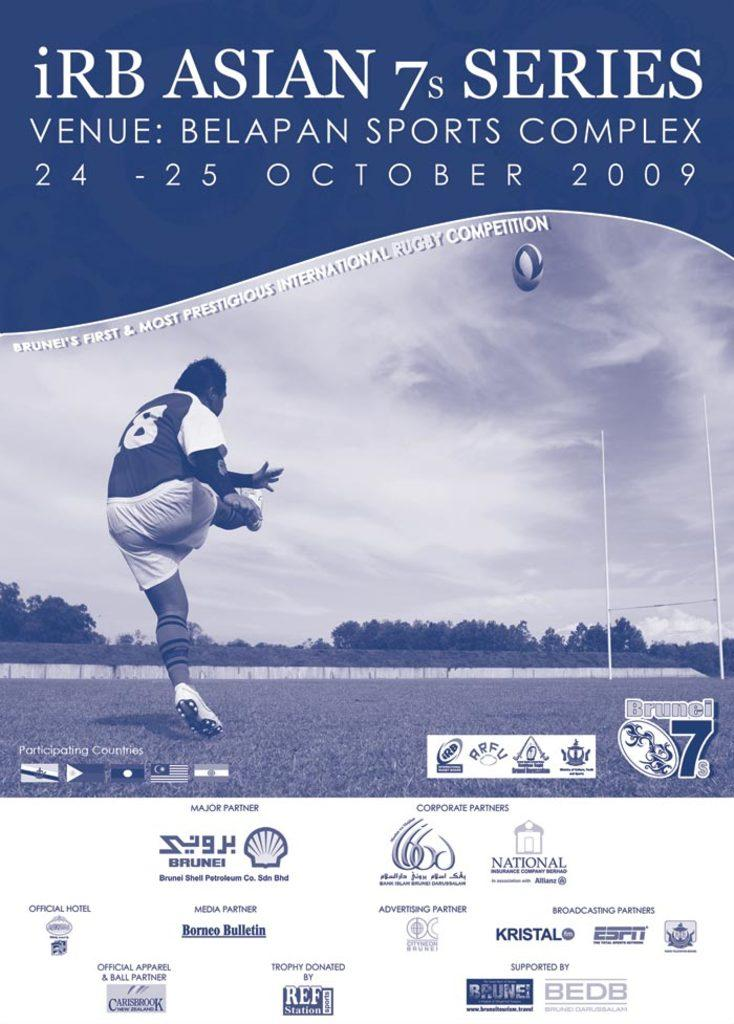What is featured on the poster in the image? There is a poster in the image. What is the person in the image doing? The person is on the ground in the image. What object can be seen in the image besides the poster and the person? There is a ball in the image. What type of natural scenery is visible in the image? There are trees and sky visible in the image. What is written or depicted on the poster? There is some text on the poster. Can you tell me how many spoons are depicted on the poster? There is no spoon present on the poster; it only contains text. What type of fruit is shown growing on the trees in the image? There is no fruit visible on the trees in the image; only the trees themselves are present. 